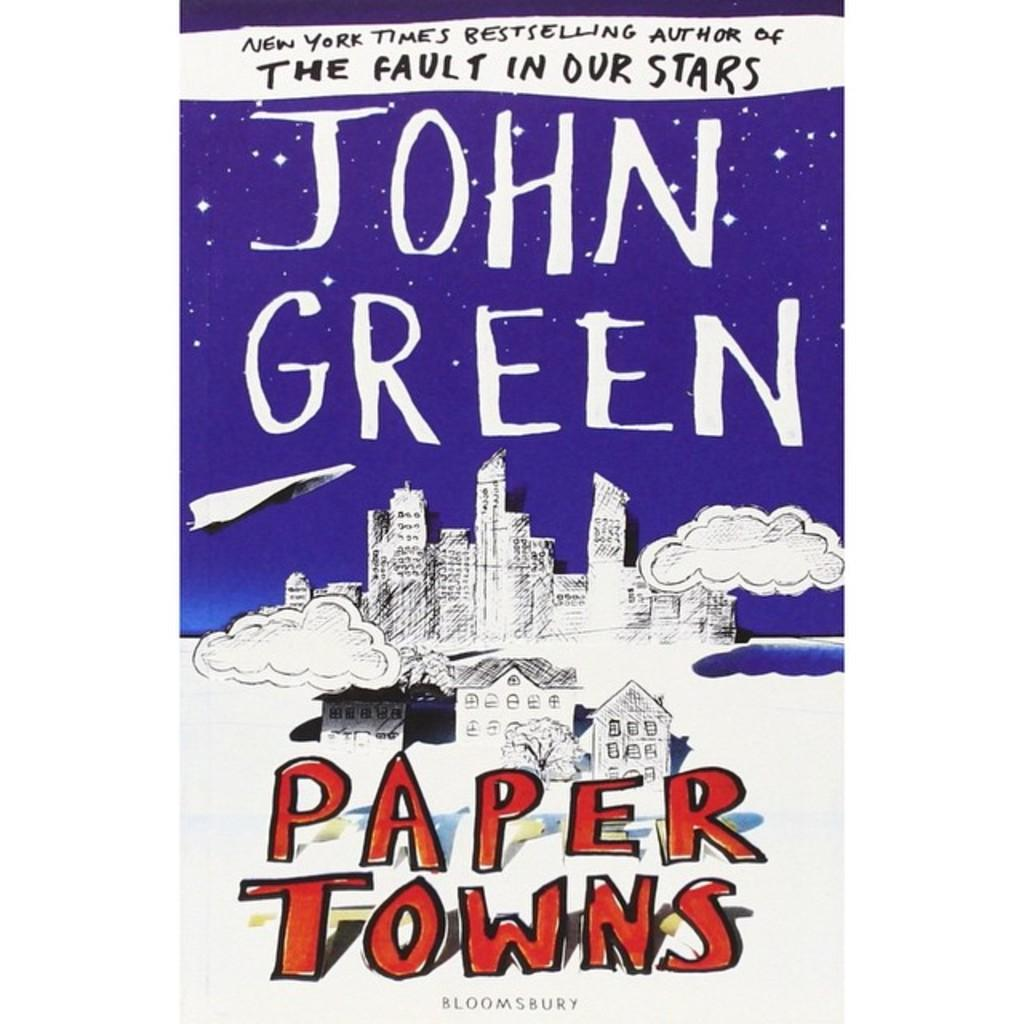<image>
Create a compact narrative representing the image presented. The author of the book The Fault in Our Stars wrote another book called Paper Towns. 